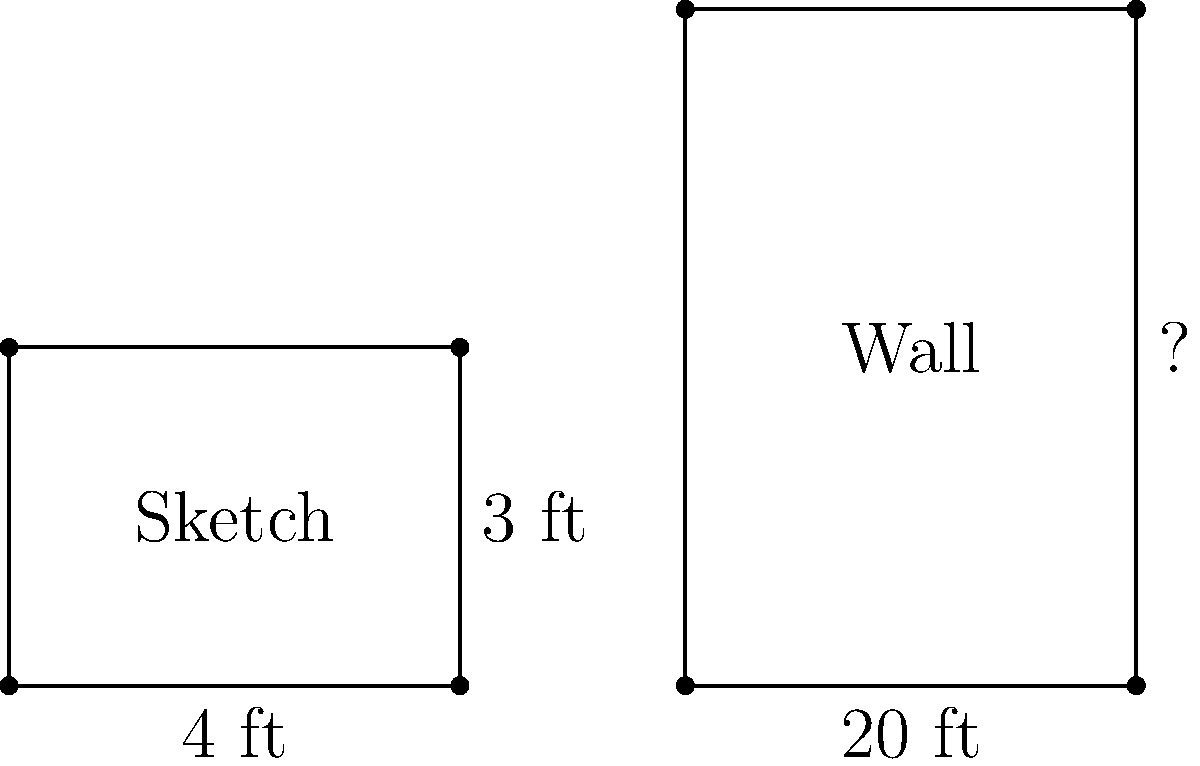You're planning to transfer a sketch of a historical scene onto a large wall for a mural. Your sketch is 4 feet wide and 3 feet tall. If you want to scale this up to fit a wall that is 20 feet wide, how tall should the mural be to maintain the original proportions? To maintain the original proportions when scaling up the sketch, we need to use the concept of similar triangles. The ratio of width to height should remain constant.

Let's approach this step-by-step:

1) First, let's identify the ratios:
   Original sketch: 4 ft wide, 3 ft tall
   Wall mural: 20 ft wide, unknown height (let's call it $h$)

2) We can set up a proportion:
   $\frac{\text{original width}}{\text{original height}} = \frac{\text{new width}}{\text{new height}}$

3) Plugging in the values:
   $\frac{4}{3} = \frac{20}{h}$

4) Cross multiply:
   $4h = 3 \times 20$

5) Solve for $h$:
   $h = \frac{3 \times 20}{4} = 15$

Therefore, to maintain the original proportions, the mural should be 15 feet tall.

We can verify this:
Original ratio: $\frac{4}{3} = 1.33$
New ratio: $\frac{20}{15} = 1.33$

The ratios are the same, confirming that the proportions are maintained.
Answer: 15 feet 